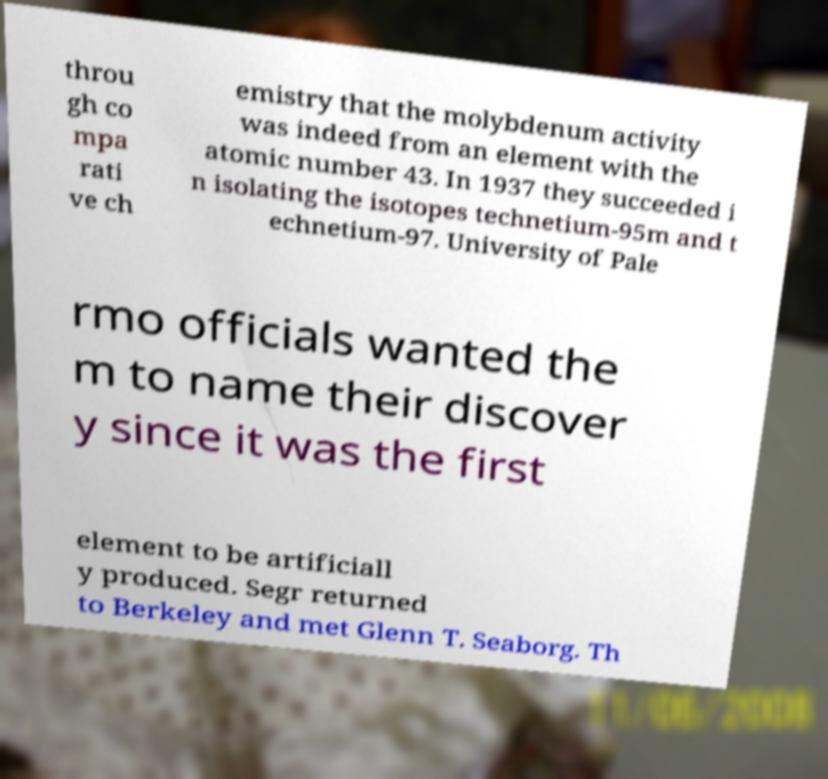Please read and relay the text visible in this image. What does it say? throu gh co mpa rati ve ch emistry that the molybdenum activity was indeed from an element with the atomic number 43. In 1937 they succeeded i n isolating the isotopes technetium-95m and t echnetium-97. University of Pale rmo officials wanted the m to name their discover y since it was the first element to be artificiall y produced. Segr returned to Berkeley and met Glenn T. Seaborg. Th 